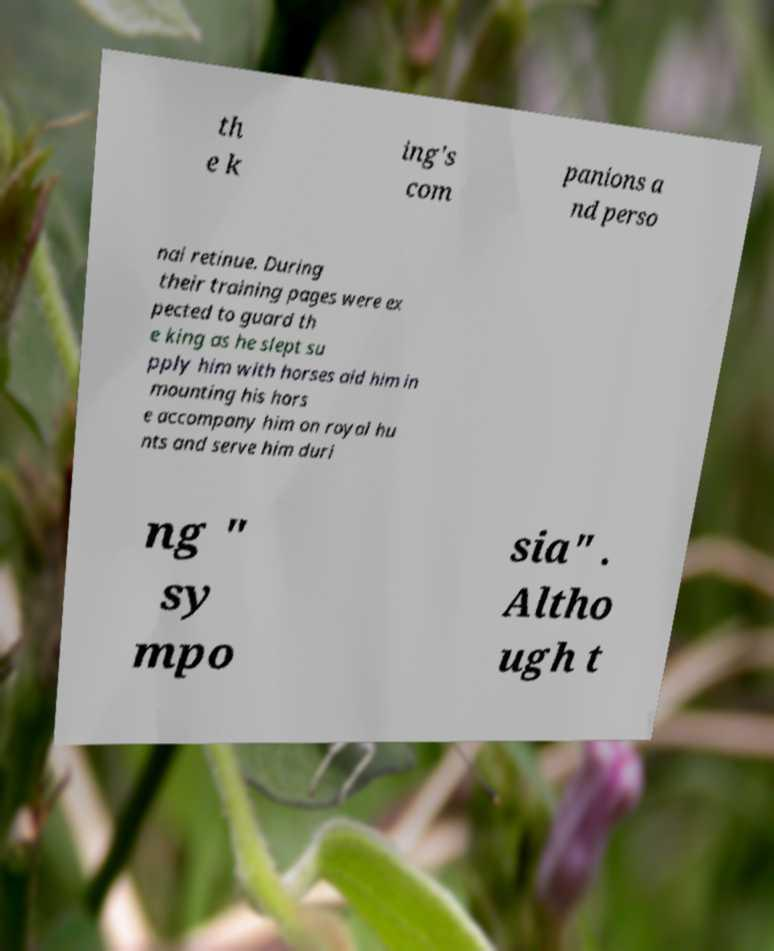Can you read and provide the text displayed in the image?This photo seems to have some interesting text. Can you extract and type it out for me? th e k ing's com panions a nd perso nal retinue. During their training pages were ex pected to guard th e king as he slept su pply him with horses aid him in mounting his hors e accompany him on royal hu nts and serve him duri ng " sy mpo sia" . Altho ugh t 